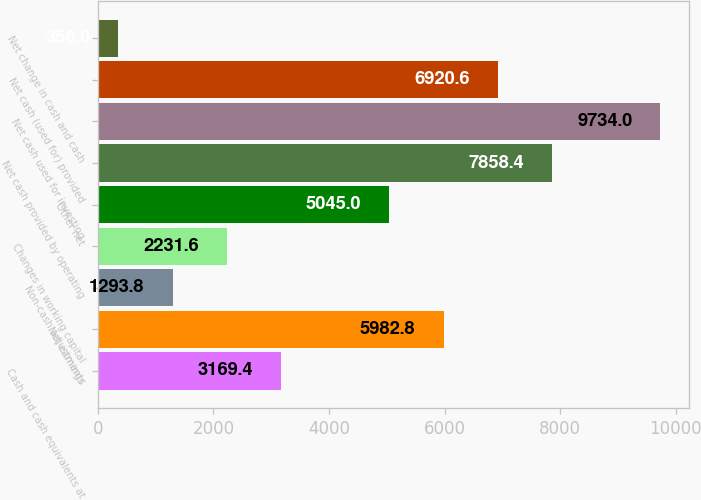<chart> <loc_0><loc_0><loc_500><loc_500><bar_chart><fcel>Cash and cash equivalents at<fcel>Net earnings<fcel>Non-cash adjustments<fcel>Changes in working capital<fcel>Other net<fcel>Net cash provided by operating<fcel>Net cash used for investing<fcel>Net cash (used for) provided<fcel>Net change in cash and cash<nl><fcel>3169.4<fcel>5982.8<fcel>1293.8<fcel>2231.6<fcel>5045<fcel>7858.4<fcel>9734<fcel>6920.6<fcel>356<nl></chart> 